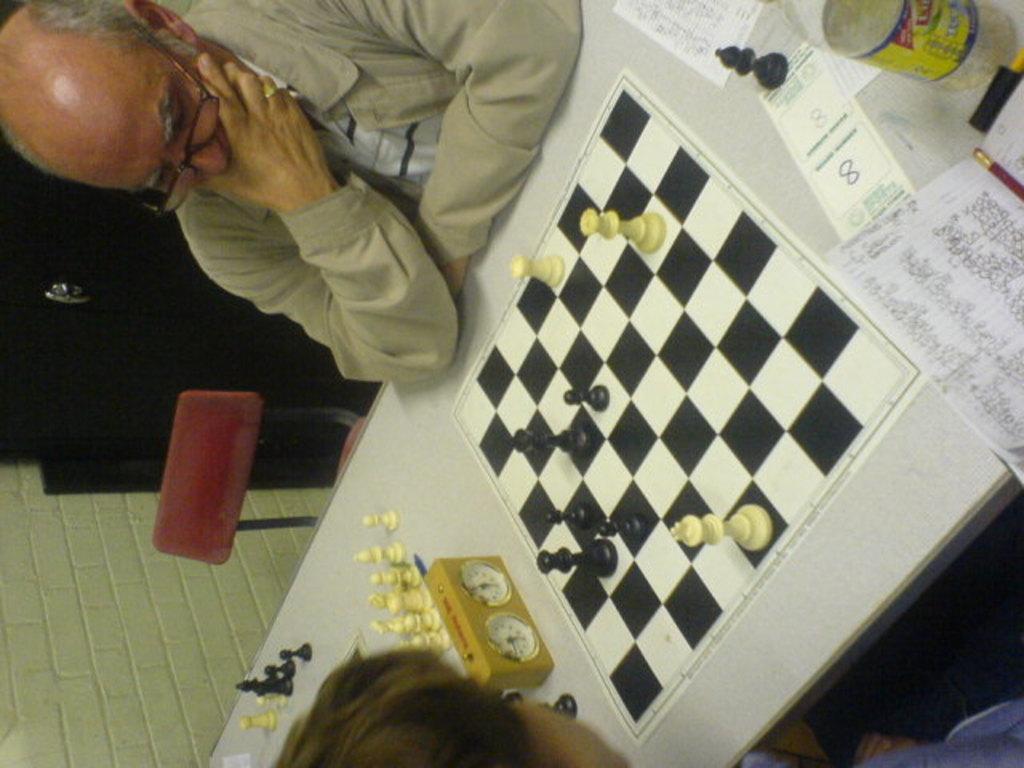Describe this image in one or two sentences. In this image we can see persons sitting at the table. On the table we can see stopwatch, chess board, papers and bottle. In the background we can see chair, cupboard and wall. 